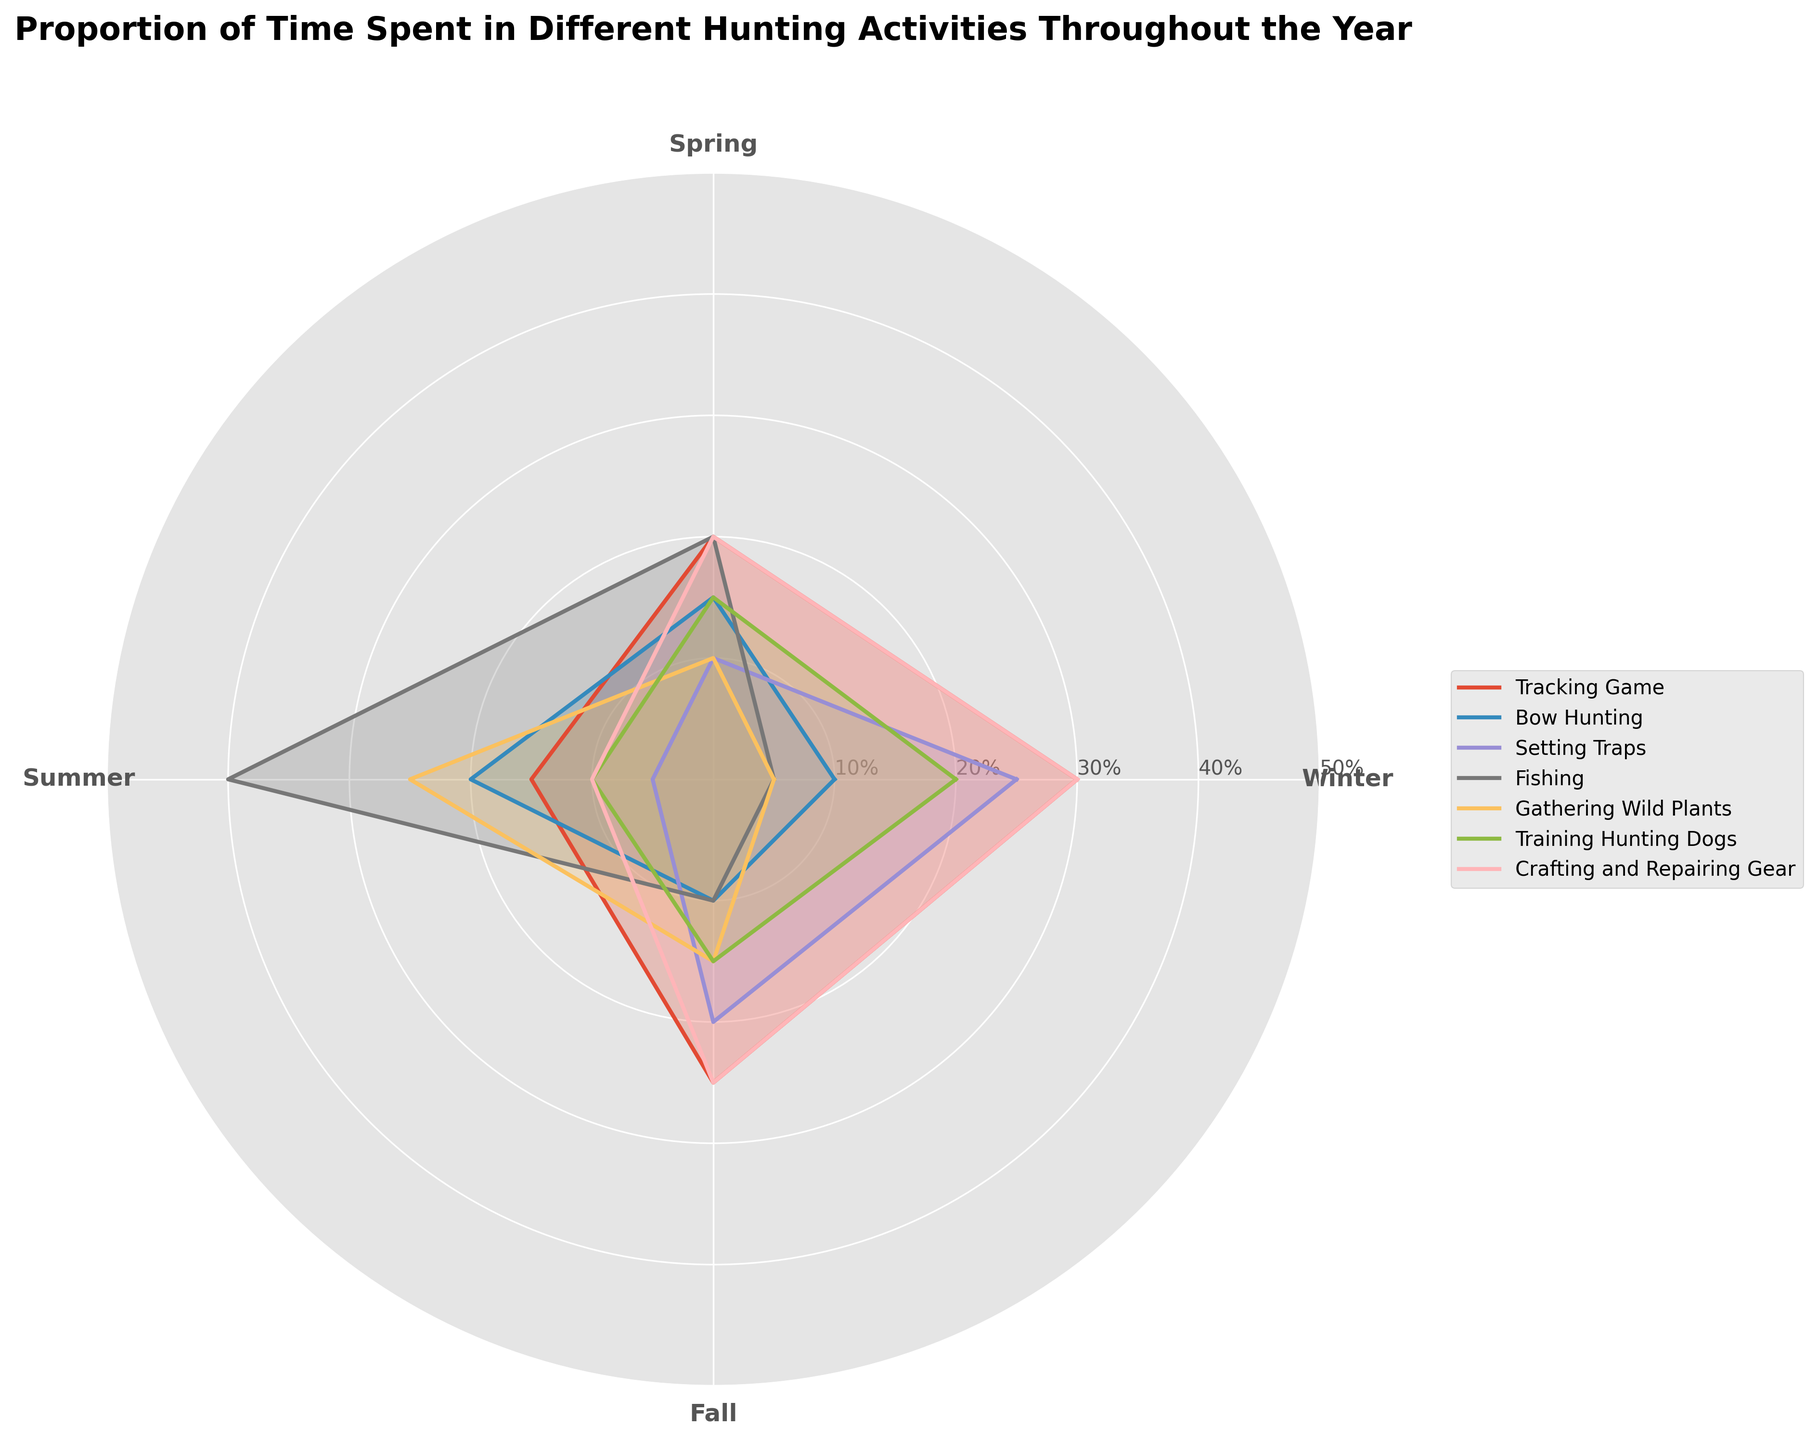What is the title of the polar area chart? The title of the polar area chart is found at the top of the plot and provides a summary of what is being shown.
Answer: Proportion of Time Spent in Different Hunting Activities Throughout the Year Which activity has the highest proportion of time spent in Winter? Look at the Winter section of the chart and see which activity area extends the farthest.
Answer: Tracking Game During which season is Gathering Wild Plants the most time-consuming? Identify where the segment for Gathering Wild Plants is largest.
Answer: Summer What is the average proportion of time spent in Training Hunting Dogs across all seasons? Sum the proportion values for Training Hunting Dogs across all four seasons, then divide by the number of seasons. Calculation: (20 + 15 + 10 + 15) / 4 = 60 / 4.
Answer: 15% Which activity takes the least proportion of time during Summer? Look at the Summer section and find the activity with the smallest area.
Answer: Setting Traps Compare Crafting and Repairing Gear in Winter and Summer. Which season has a higher proportion? Identify and compare the lengths of the segments for Crafting and Repairing Gear in both Winter and Summer.
Answer: Winter How much more time is spent Fishing in Summer compared to Winter? Subtract the proportion of time spent Fishing in Winter from the proportion in Summer. Calculation: 40% - 5% = 35%.
Answer: 35% Rank the activities based on the proportion of time spent in Spring from highest to lowest. Order activities by the size of their segments in the Spring section.
Answer: Tracking Game, Fishing, Bow Hunting, Training Hunting Dogs, Gathering Wild Plants, Crafting and Repairing Gear, Setting Traps What is the total proportion of time spent in Setting Traps during Winter and Fall? Add the proportions of time spent in Setting Traps in Winter and Fall. Calculation: 25% + 20% = 45%.
Answer: 45% Which activity shows the most consistent proportion of time spent across all seasons? Find the activity with the smallest variation in segment sizes across all seasons.
Answer: Training Hunting Dogs 